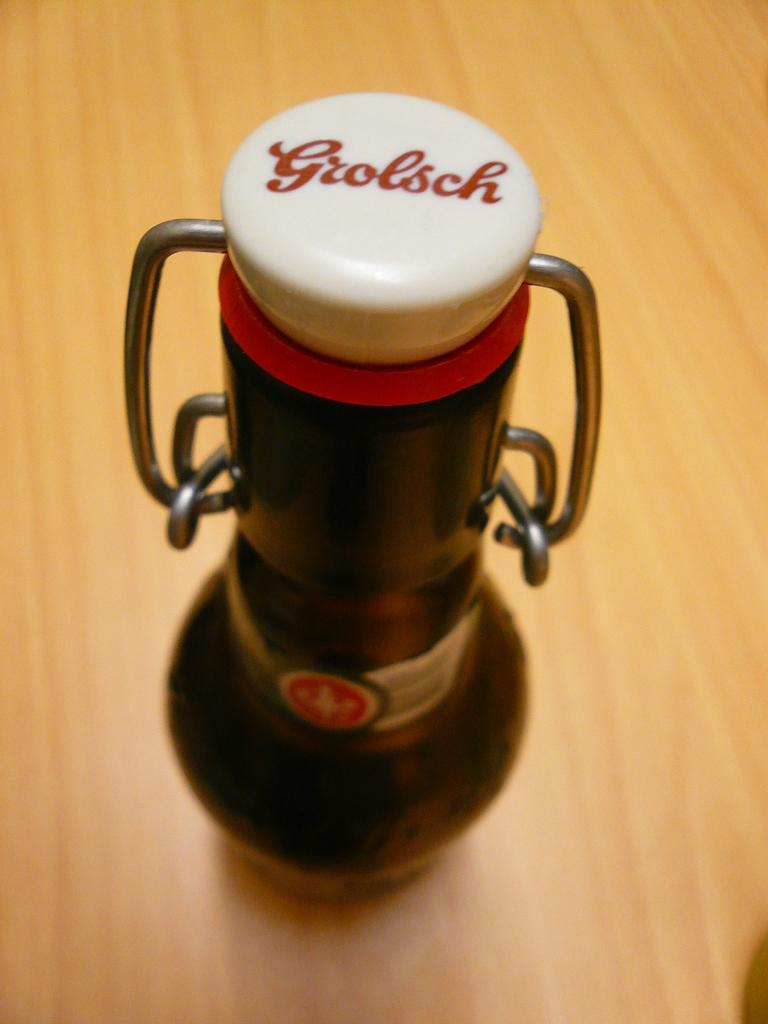<image>
Render a clear and concise summary of the photo. A bottle sits on a table and it has a white lid and says Grolsch on it in red letters. 